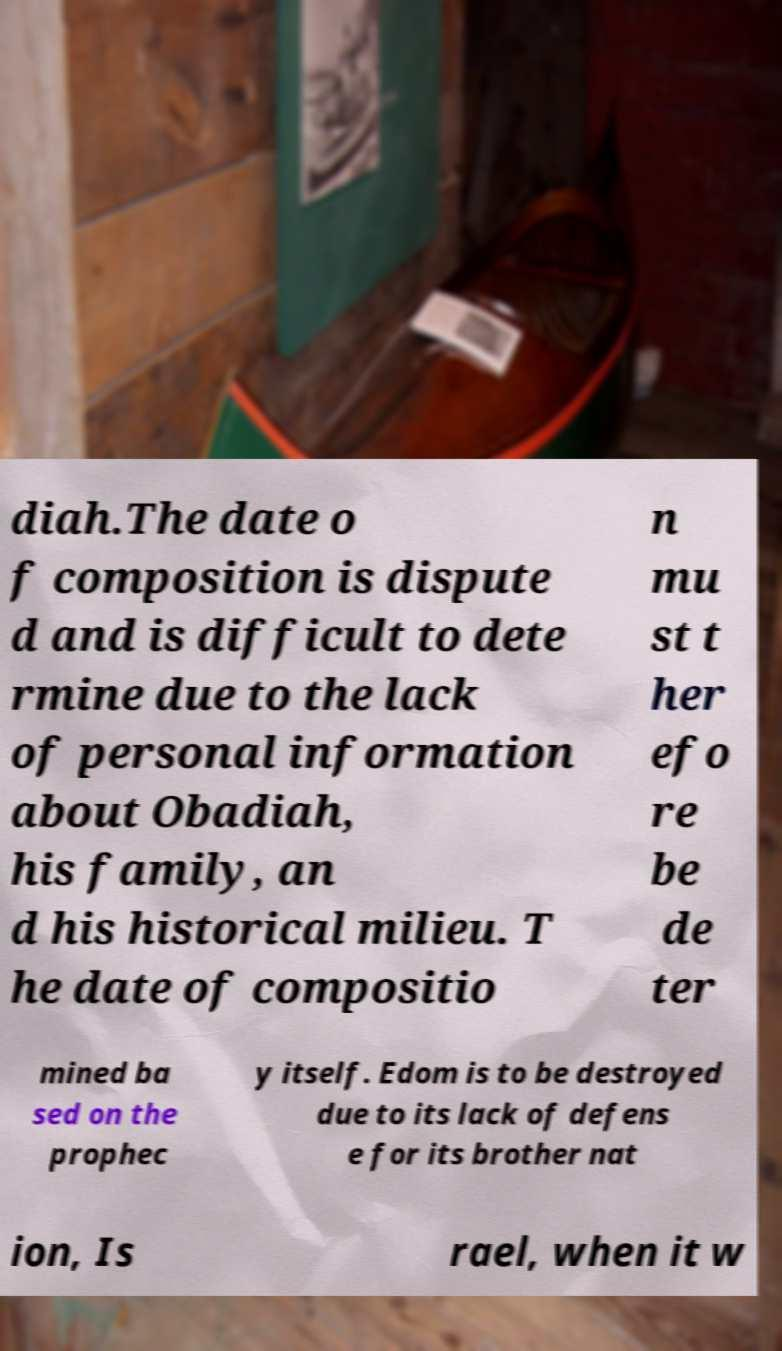Can you read and provide the text displayed in the image?This photo seems to have some interesting text. Can you extract and type it out for me? diah.The date o f composition is dispute d and is difficult to dete rmine due to the lack of personal information about Obadiah, his family, an d his historical milieu. T he date of compositio n mu st t her efo re be de ter mined ba sed on the prophec y itself. Edom is to be destroyed due to its lack of defens e for its brother nat ion, Is rael, when it w 